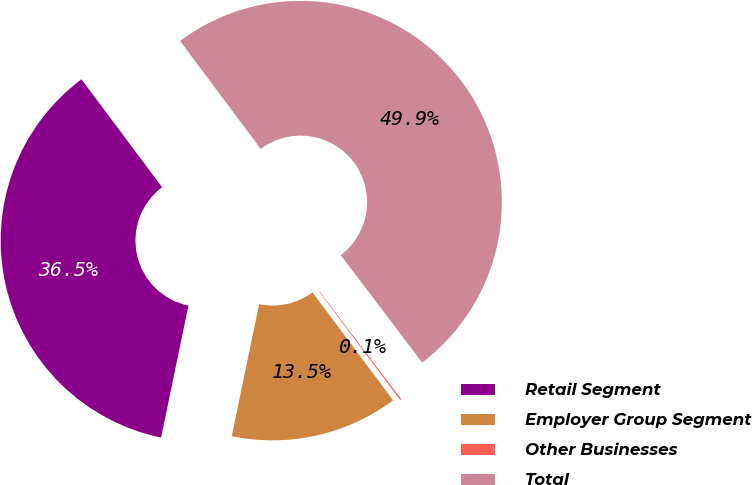<chart> <loc_0><loc_0><loc_500><loc_500><pie_chart><fcel>Retail Segment<fcel>Employer Group Segment<fcel>Other Businesses<fcel>Total<nl><fcel>36.53%<fcel>13.47%<fcel>0.11%<fcel>49.89%<nl></chart> 